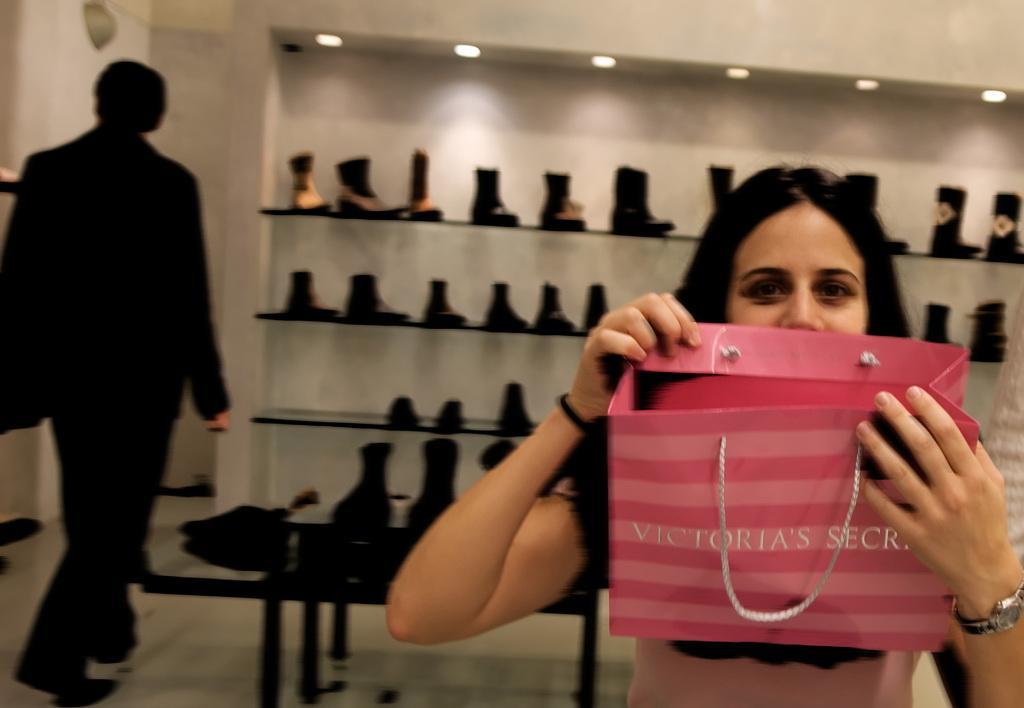Could you give a brief overview of what you see in this image? In this image, we can see a lady holding bag and in the background, there is a man walking and we can see some shoes in the shelf. At the top, there are lights. 